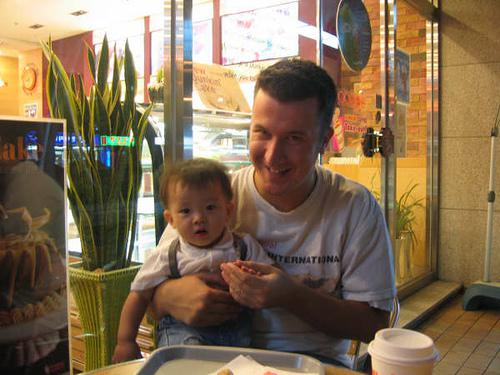Question: why is he holding baby?
Choices:
A. For a photo.
B. For the mother.
C. For the babysitter.
D. For the look of it.
Answer with the letter. Answer: A Question: when have they eaten?
Choices:
A. Yesterday.
B. Last week.
C. This morning.
D. Just recently.
Answer with the letter. Answer: D Question: what race is the baby?
Choices:
A. Black.
B. Latino.
C. Caucasion.
D. Asian.
Answer with the letter. Answer: D Question: what are they sitting near?
Choices:
A. A bar.
B. A chair.
C. A bench.
D. A restaurant table.
Answer with the letter. Answer: D Question: what is seen in the window?
Choices:
A. A cat.
B. A lamp.
C. A window shade.
D. A potted plant.
Answer with the letter. Answer: D 